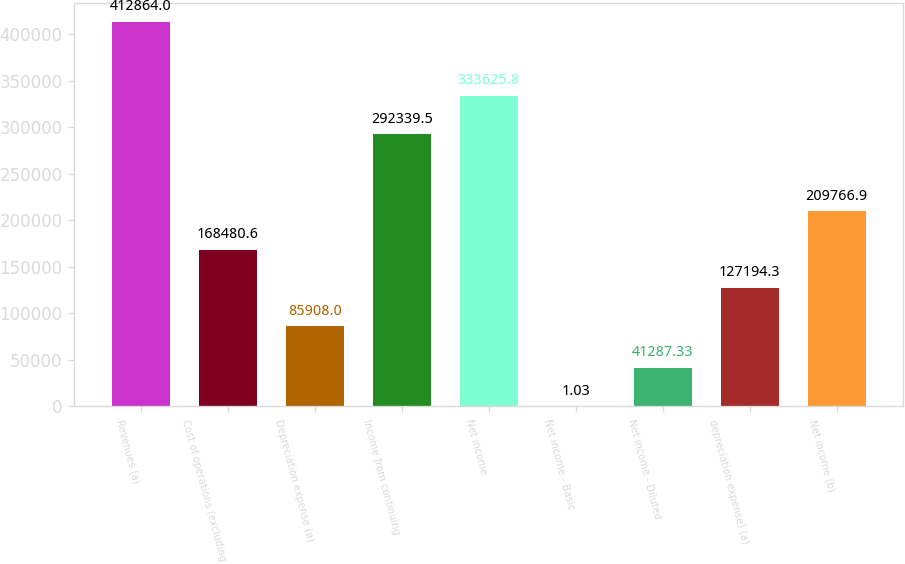Convert chart. <chart><loc_0><loc_0><loc_500><loc_500><bar_chart><fcel>Revenues (a)<fcel>Cost of operations (excluding<fcel>Depreciation expense (a)<fcel>Income from continuing<fcel>Net income<fcel>Net income - Basic<fcel>Net income - Diluted<fcel>depreciation expense) (a)<fcel>Net income (b)<nl><fcel>412864<fcel>168481<fcel>85908<fcel>292340<fcel>333626<fcel>1.03<fcel>41287.3<fcel>127194<fcel>209767<nl></chart> 